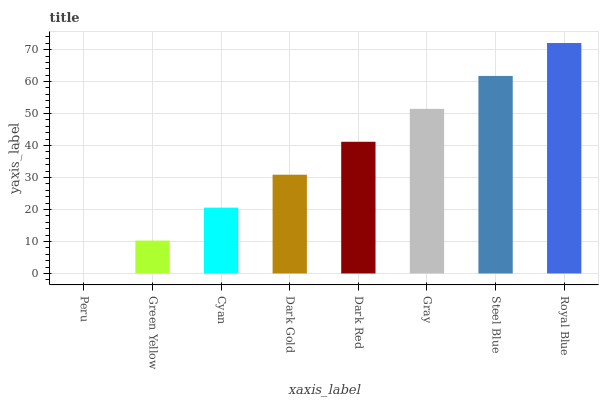Is Green Yellow the minimum?
Answer yes or no. No. Is Green Yellow the maximum?
Answer yes or no. No. Is Green Yellow greater than Peru?
Answer yes or no. Yes. Is Peru less than Green Yellow?
Answer yes or no. Yes. Is Peru greater than Green Yellow?
Answer yes or no. No. Is Green Yellow less than Peru?
Answer yes or no. No. Is Dark Red the high median?
Answer yes or no. Yes. Is Dark Gold the low median?
Answer yes or no. Yes. Is Steel Blue the high median?
Answer yes or no. No. Is Gray the low median?
Answer yes or no. No. 